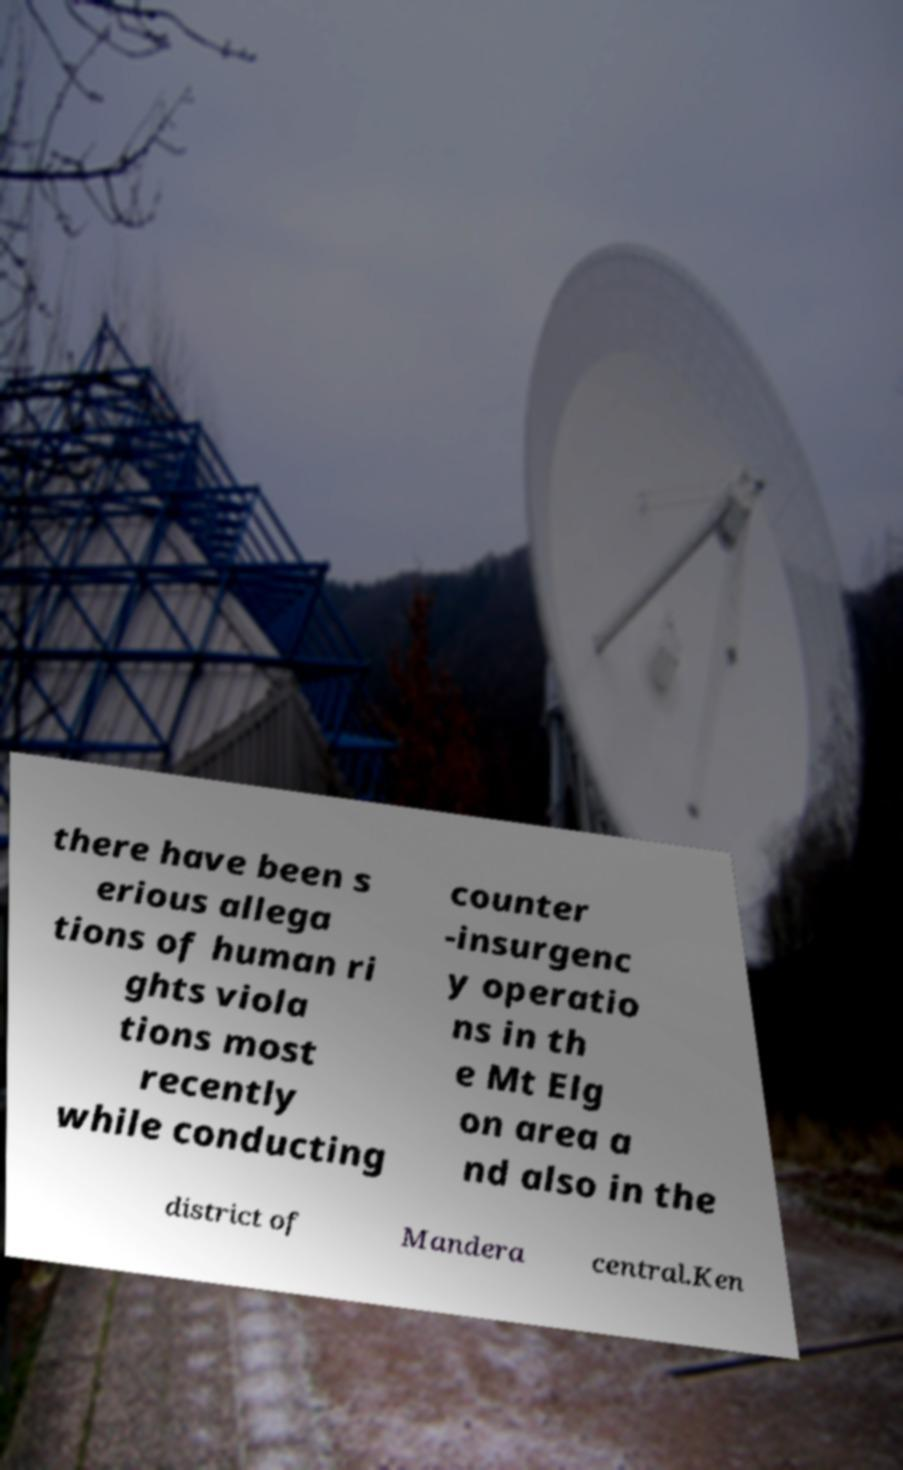Please identify and transcribe the text found in this image. there have been s erious allega tions of human ri ghts viola tions most recently while conducting counter -insurgenc y operatio ns in th e Mt Elg on area a nd also in the district of Mandera central.Ken 